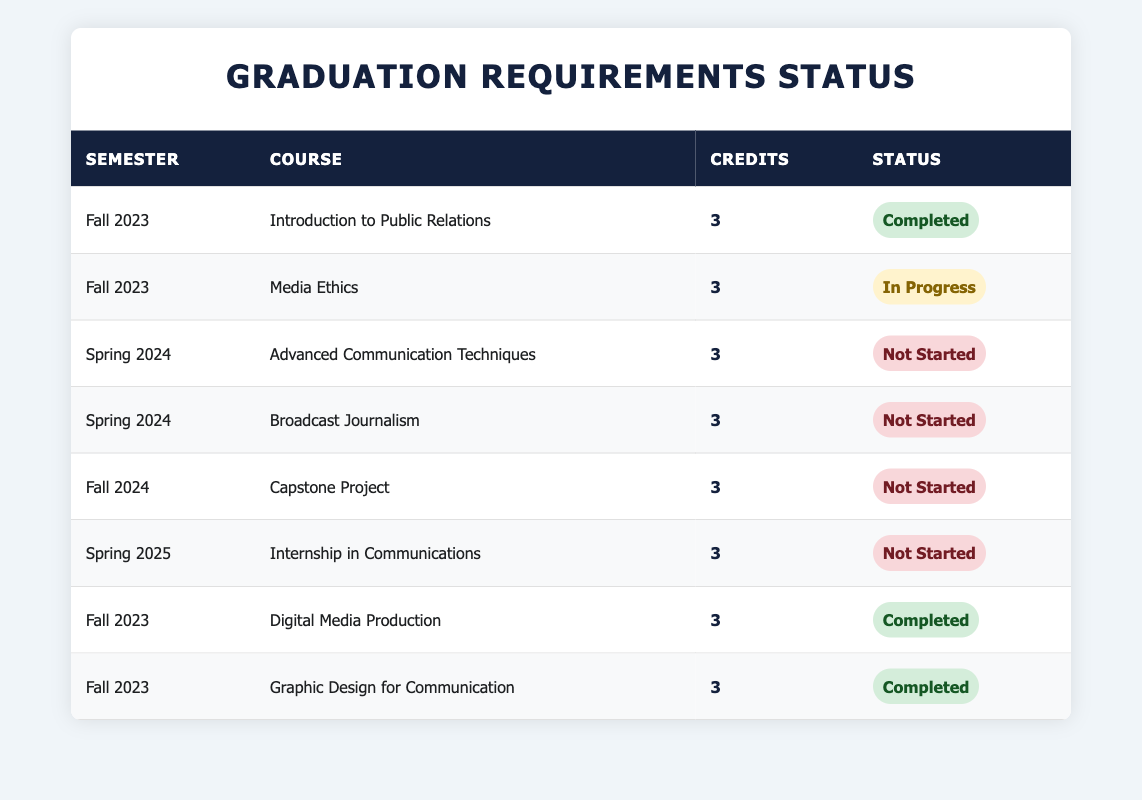What is the total number of credits for completed courses in Fall 2023? In Fall 2023, there are three completed courses: Introduction to Public Relations, Digital Media Production, and Graphic Design for Communication, each worth 3 credits. So, the total credits are (3 + 3 + 3) = 9.
Answer: 9 How many courses are still in progress for the Spring 2024 semester? There are two courses listed for Spring 2024: Advanced Communication Techniques and Broadcast Journalism, both of which have the status "Not Started." Therefore, there are no courses in progress for this semester.
Answer: 0 Is Media Ethics the only course with an "In Progress" status? Media Ethics is listed as "In Progress," and it is the only course currently in that status for Fall 2023. Therefore, the answer is yes.
Answer: Yes What is the total number of courses that have not started yet? There are four courses that have not started: Advanced Communication Techniques, Broadcast Journalism, Capstone Project, and Internship in Communications. Adding those gives a total of 4 not started courses.
Answer: 4 In which semester is the course "Digital Media Production" scheduled, and what is its status? The course "Digital Media Production" is scheduled for Fall 2023, and its status is "Completed." So the answer includes the semester and the status.
Answer: Fall 2023, Completed What is the difference in the number of completed courses between Fall 2023 and Spring 2024? In Fall 2023, there are three completed courses (Introduction to Public Relations, Digital Media Production, and Graphic Design for Communication). In Spring 2024, there are no completed courses, as all are not started. The difference in completed courses is (3 - 0) = 3.
Answer: 3 How many credits are required to complete all courses in Fall 2023? In Fall 2023, there are four courses: Introduction to Public Relations (3 credits), Media Ethics (3 credits), Digital Media Production (3 credits), and Graphic Design for Communication (3 credits). The total number of credits required to complete all these courses is (3 + 3 + 3 + 3) = 12.
Answer: 12 Are there any completed courses scheduled for Spring 2024? No courses for Spring 2024 are listed as completed since both courses are marked as "Not Started." So the answer is no.
Answer: No What is the status of the course with the highest credit value scheduled for Fall 2024? The only course listed for Fall 2024 is the Capstone Project, which has not started yet. Thus, the answer relates to the status of this course.
Answer: Not Started 